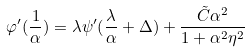Convert formula to latex. <formula><loc_0><loc_0><loc_500><loc_500>\varphi ^ { \prime } ( \frac { 1 } { \alpha } ) = \lambda \psi ^ { \prime } ( \frac { \lambda } { \alpha } + \Delta ) + \frac { \tilde { C } \alpha ^ { 2 } } { 1 + \alpha ^ { 2 } \eta ^ { 2 } }</formula> 